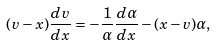Convert formula to latex. <formula><loc_0><loc_0><loc_500><loc_500>( v - x ) \frac { d v } { d x } = - \frac { 1 } { \alpha } \frac { d \alpha } { d x } - ( x - v ) \alpha ,</formula> 